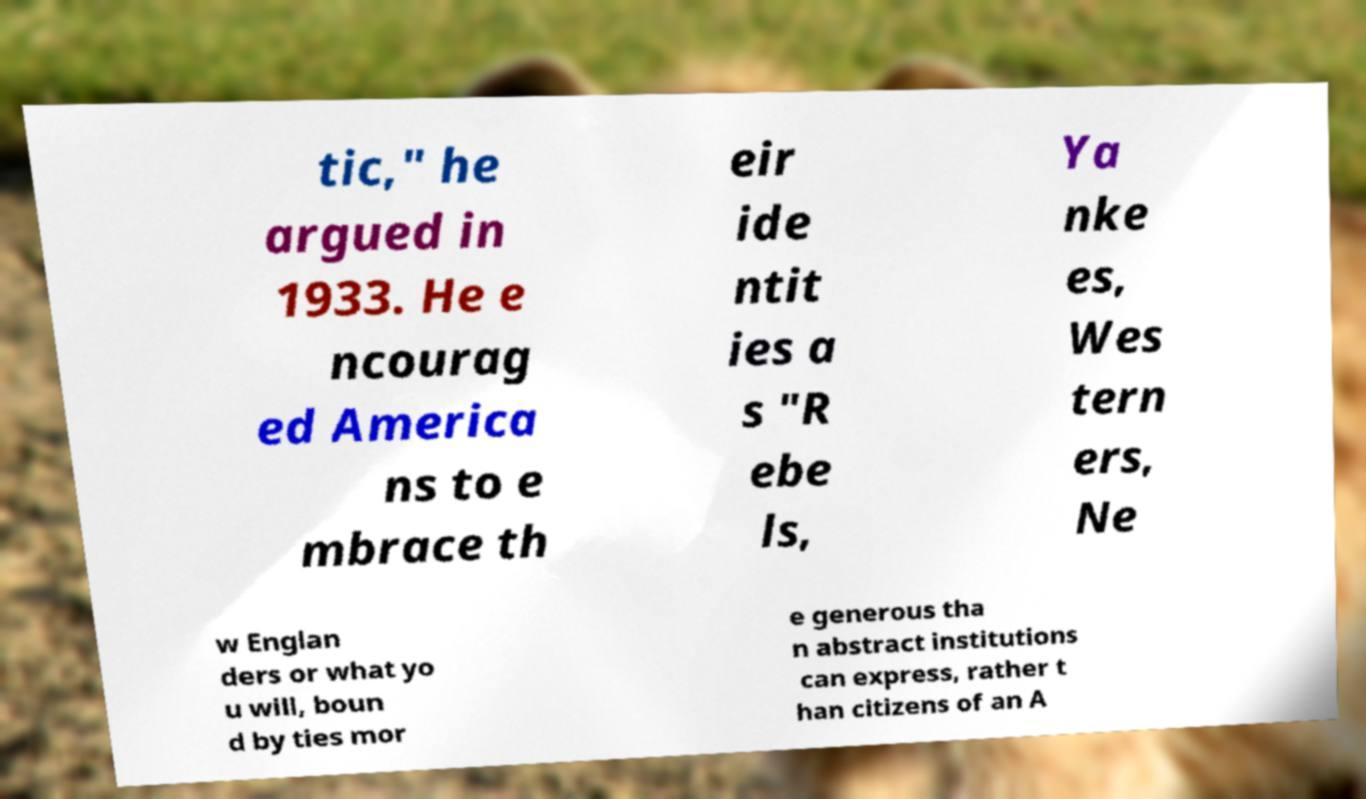I need the written content from this picture converted into text. Can you do that? tic," he argued in 1933. He e ncourag ed America ns to e mbrace th eir ide ntit ies a s "R ebe ls, Ya nke es, Wes tern ers, Ne w Englan ders or what yo u will, boun d by ties mor e generous tha n abstract institutions can express, rather t han citizens of an A 